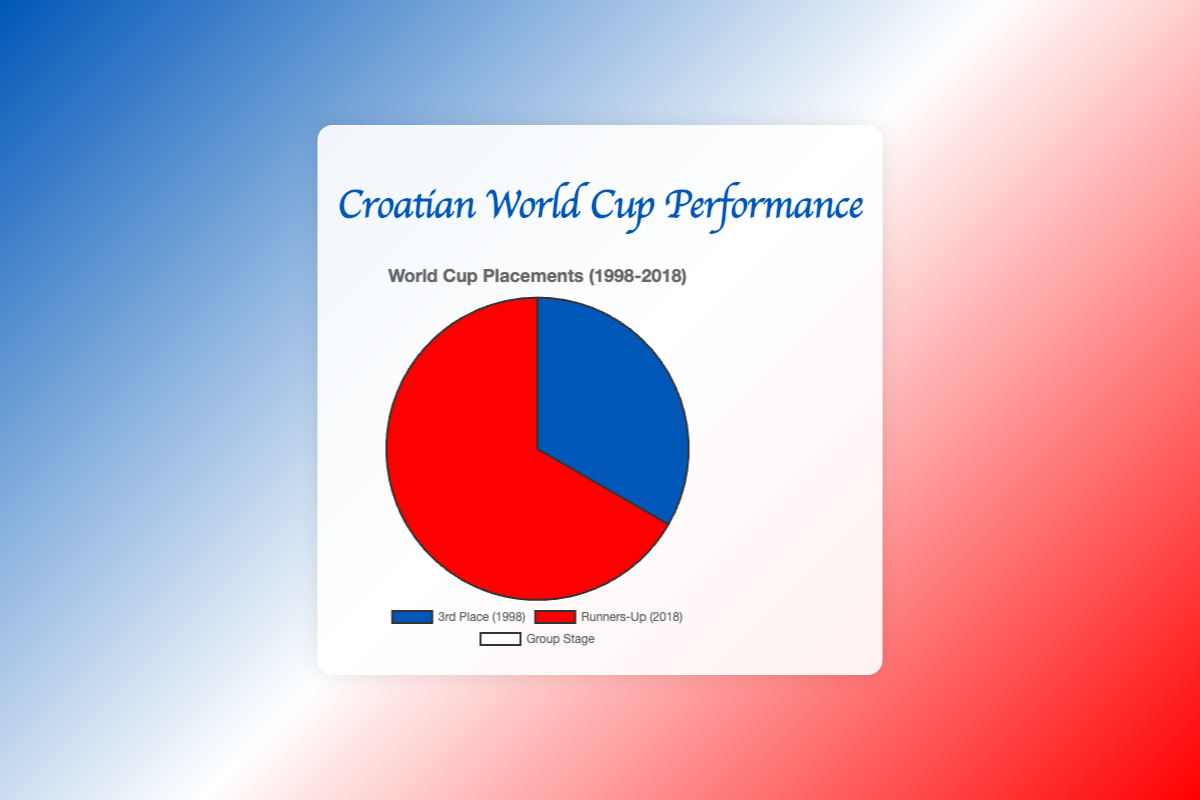How many different placements has Croatia achieved in World Cups from 1998 to 2018? By analyzing the labels, we see three different placements: '3rd Place', 'Runners-Up', and 'Group Stage'. We count these categories.
Answer: 3 What percentage of Croatia’s World Cup performances resulted in them finishing as runners-up? From the chart, it's given that 'Runners-Up (2018)' makes up 66.67% of Croatia's placements.
Answer: 66.67% Did Croatia have more group stage placements or top 3 placements in this period? From the data, Croatia had three group stage placements (2002, 2006, 2014) and two top 3 placements (1998, 2018). Therefore, they had more group stage placements.
Answer: Group Stage What is the sum of the percentages of 3rd Place and Runners-Up finishes for Croatia? The percentages for 3rd Place (1998) and Runners-Up (2018) are 33.33% and 66.67%, respectively. Adding them together: 33.33% + 66.67% = 100%.
Answer: 100% Comparing the 3rd Place (1998) and Group Stage placements, which one has a higher percentage? The 3rd Place (1998) has a percentage of 33.33%, while the Group Stage placements collectively have a percentage of 0%. Hence, 3rd Place (1998) has a higher percentage.
Answer: 3rd Place (1998) What color represents Croatia's Runners-Up performance? By referring to the visual colors in the chart, the color associated with 'Runners-Up (2018)' is red.
Answer: Red How many years did Croatia fail to progress past the group stage in this timeframe? By counting the 'Group Stage' placements (2002, 2006, 2014), we find three years where Croatia did not progress past the group stage.
Answer: 3 If the chart were updated to include 2022 and Croatia placed 1st, what would be the new percentage for Runners-Up (2018)? First, calculate the new total placements: 5 current + 1 new = 6 total. Previously it was 66.67% of 3 (as 2018 was 1 out of 5). Now it will be 1 out of 6. Thus, (1/6) * 100 = 16.67%.
Answer: 16.67% Are the 'Group Stage' placements color-coded with a single color? Observing the chart, the 'Group Stage' placements are all represented by the color white.
Answer: White 